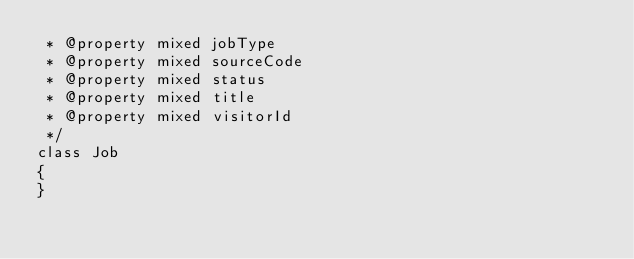<code> <loc_0><loc_0><loc_500><loc_500><_PHP_> * @property mixed jobType
 * @property mixed sourceCode
 * @property mixed status
 * @property mixed title
 * @property mixed visitorId
 */
class Job
{
}
</code> 